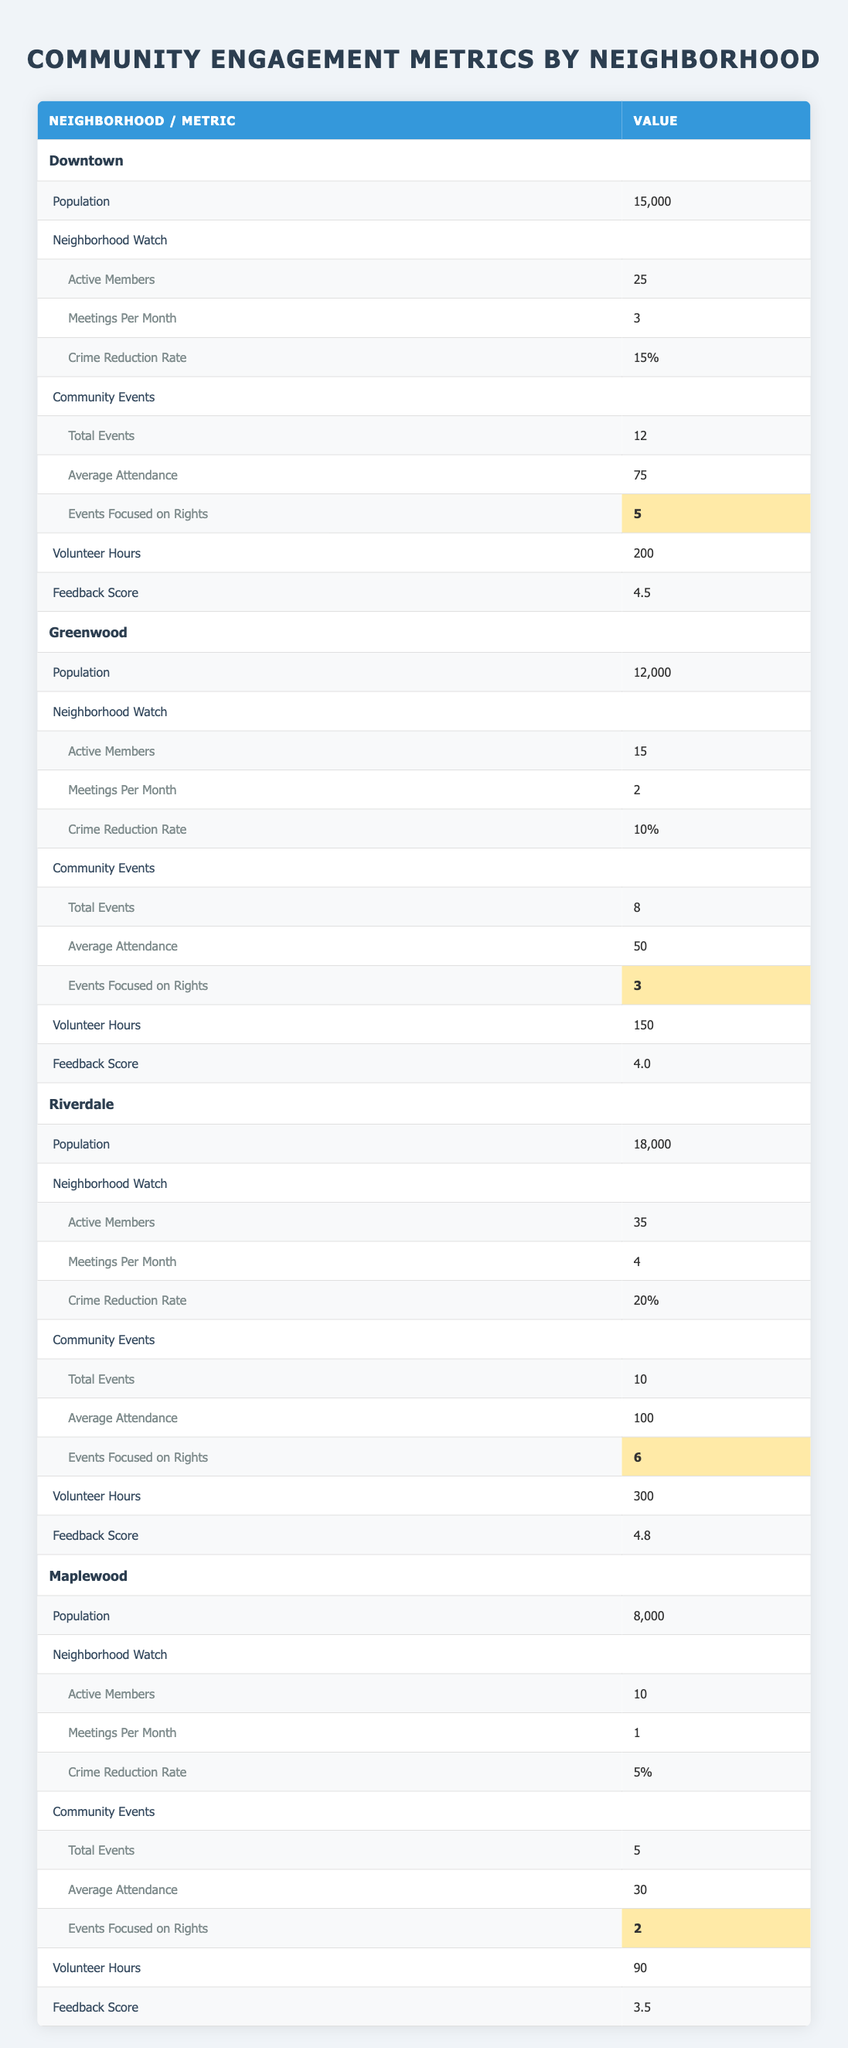What is the population of Riverdale? The table lists "Population" under the "Riverdale" section, and the value provided is "18,000".
Answer: 18,000 How many active members are in the Neighborhood Watch for Downtown? Under "Neighborhood Watch" for "Downtown," the "Active Members" value is provided, which is "25".
Answer: 25 Which neighborhood has the highest crime reduction rate? The crime reduction rates for each neighborhood are compared: Downtown (15%), Greenwood (10%), Riverdale (20%), and Maplewood (5%). Riverdale has the highest rate of 20%.
Answer: Riverdale What is the average attendance at community events in Greenwood? The table shows that Greenwood has an "Average Attendance" value of "50" for community events.
Answer: 50 How many total community events were held across all neighborhoods? The total number of events is found by adding the "Total Events" values for each neighborhood: Downtown (12) + Greenwood (8) + Riverdale (10) + Maplewood (5) = 35.
Answer: 35 Is the feedback score for Maplewood greater than 4? The feedback score for Maplewood is stated to be "3.5", which is less than 4. Therefore, the answer is no.
Answer: No Which neighborhood organized the most events focused on rights? The counts of events focused on rights are: Downtown (5), Greenwood (3), Riverdale (6), and Maplewood (2). Riverdale organized the most events, totaling 6.
Answer: Riverdale What is the difference in volunteer hours between Riverdale and Downtown? Riverdale has "300" volunteer hours and Downtown has "200" volunteer hours. The difference is calculated as 300 - 200 = 100.
Answer: 100 Did Greenwood hold more community events than Maplewood? Greenwood had "8" total events, while Maplewood had "5". Since 8 is greater than 5, the answer is yes.
Answer: Yes 